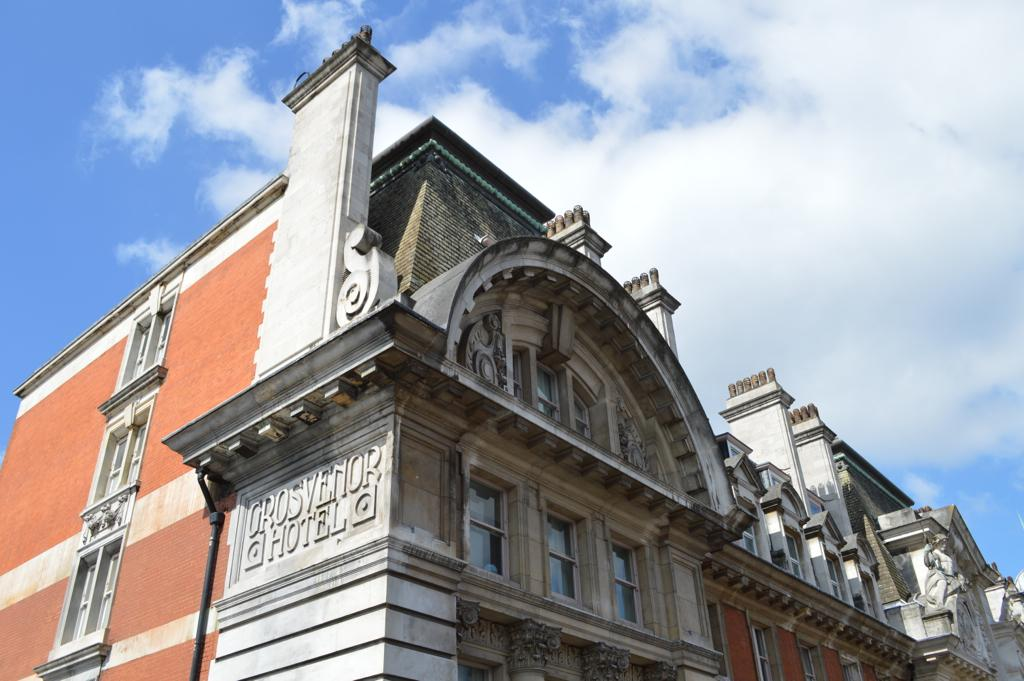What type of structure is in the image? There is a building in the image. What feature can be seen on the building? The building has windows. What is written or displayed on the building? Something is written on the building. What can be seen in the background of the image? There is sky visible in the background of the image. What is the condition of the sky in the image? Clouds are present in the sky. Can you tell me how many legs the building has in the image? Buildings do not have legs; they are stationary structures. The question is not applicable to the image. 